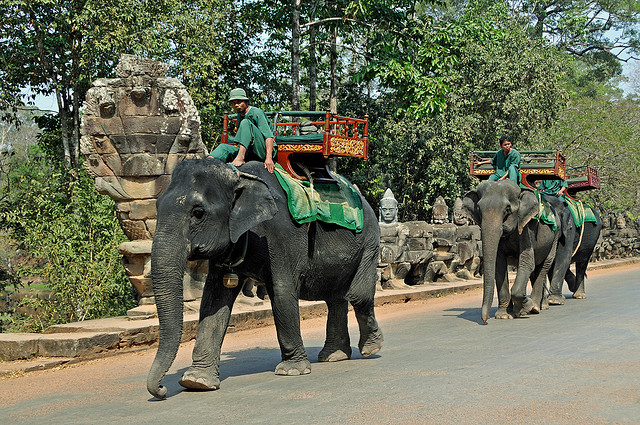Are elephant rides still common in Thailand? While elephant rides were once a common tourist activity in Thailand, awareness of animal welfare has led to a decrease in this practice. Many conservationists argue that elephant rides can be harmful and stressful for the animals. As a result, there's been a shift towards more ethical experiences that do not involve riding, allowing tourists to interact with elephants in ways that promote their well-being. 